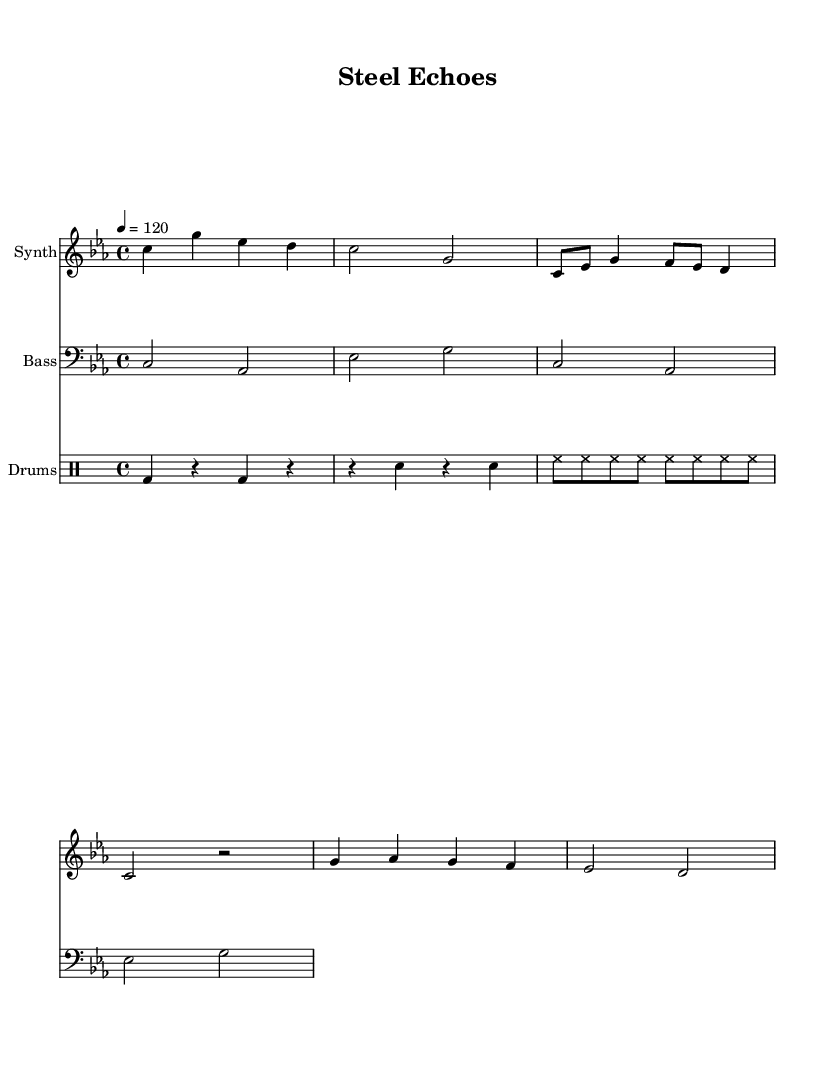What is the key signature of this music? The key signature is indicated at the beginning of the staff. In this case, it shows three flats, which corresponds to C minor.
Answer: C minor What is the time signature of this music? The time signature is located at the beginning of the score and indicates the rhythm structure. Here, it is 4/4, meaning there are four beats in a measure.
Answer: 4/4 What is the tempo marking in this piece? The tempo marking appears at the top of the score, showing the speed at which the piece should be played. It reads "4 = 120," indicating there are 120 beats per minute.
Answer: 120 How many measures are in the synthesizer part? To find the number of measures, count the groupings of vertical bar lines in the synthesizer staff. There are a total of 6 measures shown.
Answer: 6 What type of percussion is shown in the drum part? The drum part lists different symbols for each type of drum. Here, it shows a bass drum, snare drum, and hi-hat, which are common in electronic music.
Answer: Bass, Snare, Hi-hat Which chord progression is used in the bass synth part? The chord progression can be identified by looking at the notes played in the bass part. It consists of C, A flat, and E flat chords in a pattern across the measures.
Answer: C, A flat, E flat What is the instrument listed at the top of the synthesizer staff? The instrument name is displayed at the beginning of the staff, indicating which sound is produced. In this case, it states "Synth," which refers to synthesizer sounds.
Answer: Synth 